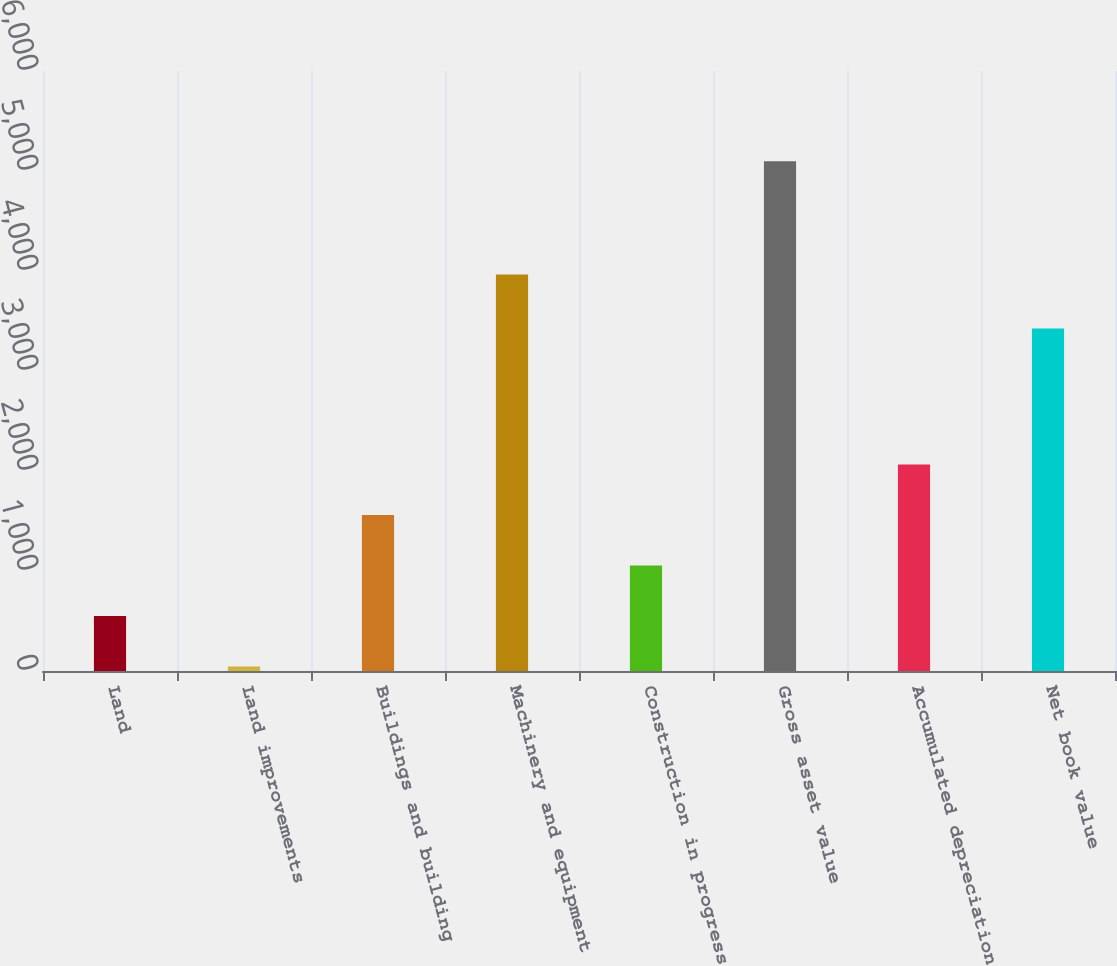<chart> <loc_0><loc_0><loc_500><loc_500><bar_chart><fcel>Land<fcel>Land improvements<fcel>Buildings and building<fcel>Machinery and equipment<fcel>Construction in progress<fcel>Gross asset value<fcel>Accumulated depreciation<fcel>Net book value<nl><fcel>549.3<fcel>44<fcel>1559.9<fcel>3965<fcel>1054.6<fcel>5097<fcel>2065.2<fcel>3425<nl></chart> 